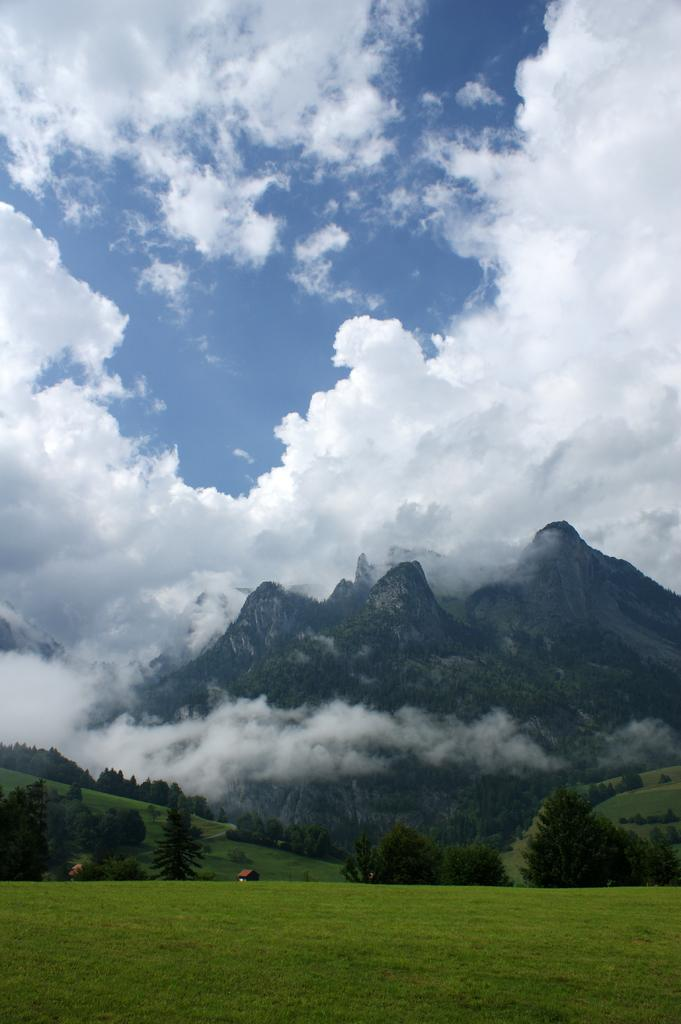What type of landscape is visible at the bottom of the image? There is farmland and grass at the bottom of the image. What structures can be seen in the background? There is a hut in the background near trees. What geographical features are visible on the right side of the image? There are mountains visible on the right side of the image. What is visible at the top of the image? The sky is visible at the top of the image. What can be observed in the sky? Clouds are present in the sky. What type of vase is placed on the mountainside in the image? There is no vase present in the image. How many people are pushing the hut in the background? There are no people pushing the hut in the background, as it is not a part of the image. 